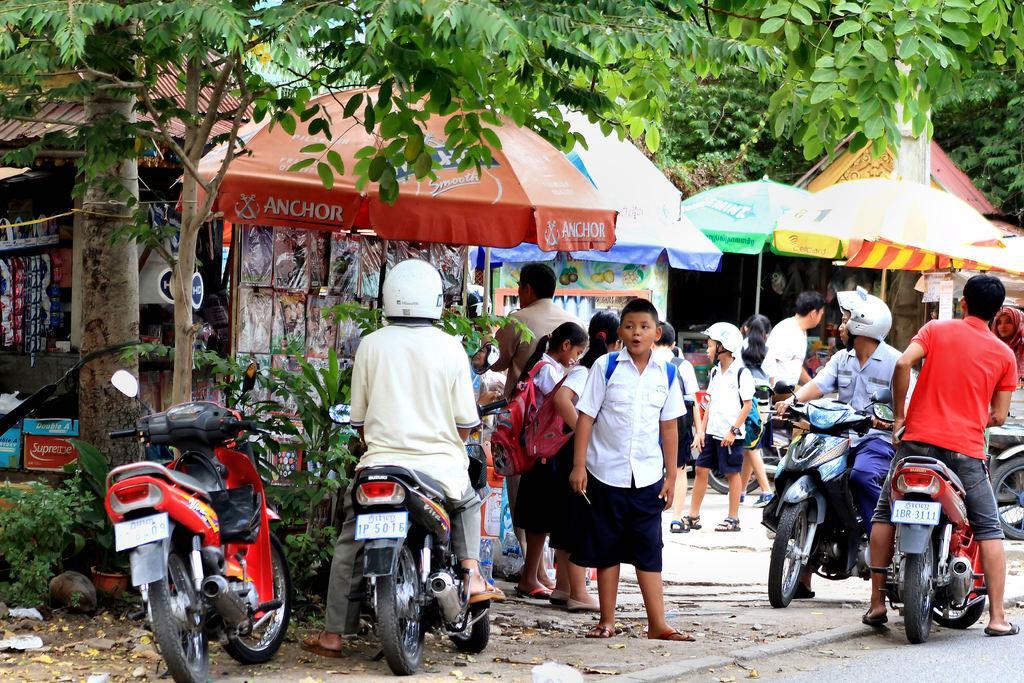Please provide a concise description of this image. Here we can see a group of people are standing, and some are sitting on the bike, and here are the tents, and here are the trees. 